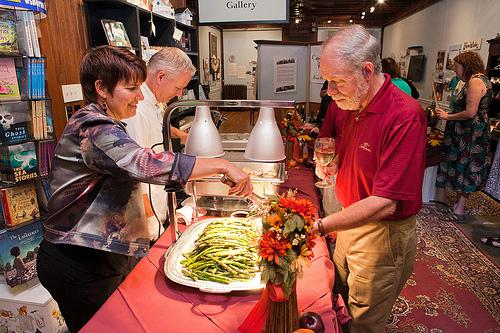Question: how many men can be seen in the picture?
Choices:
A. Three.
B. Four.
C. Five.
D. Two.
Answer with the letter. Answer: D Question: where are the flowers?
Choices:
A. In the field.
B. In the flowerpot.
C. A vase.
D. In the cup.
Answer with the letter. Answer: C Question: what is covering the table?
Choices:
A. A piece of glass.
B. Tablecloth.
C. A large cloth.
D. A bunch of books.
Answer with the letter. Answer: B 